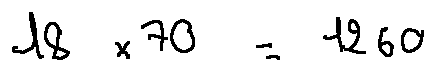Convert formula to latex. <formula><loc_0><loc_0><loc_500><loc_500>1 8 \times 7 0 = 1 2 6 0</formula> 